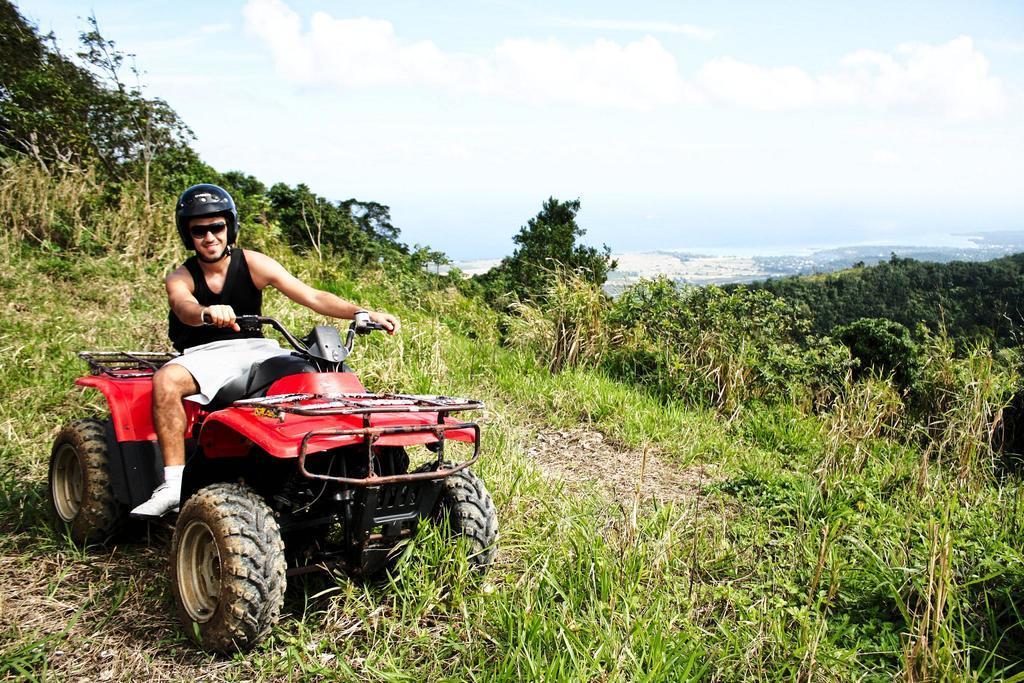How would you summarize this image in a sentence or two? On the left side of the image we can see a man, he is seated on the vehicle, he wore spectacles and a helmet, in the background we can see few plants, trees and clouds. 